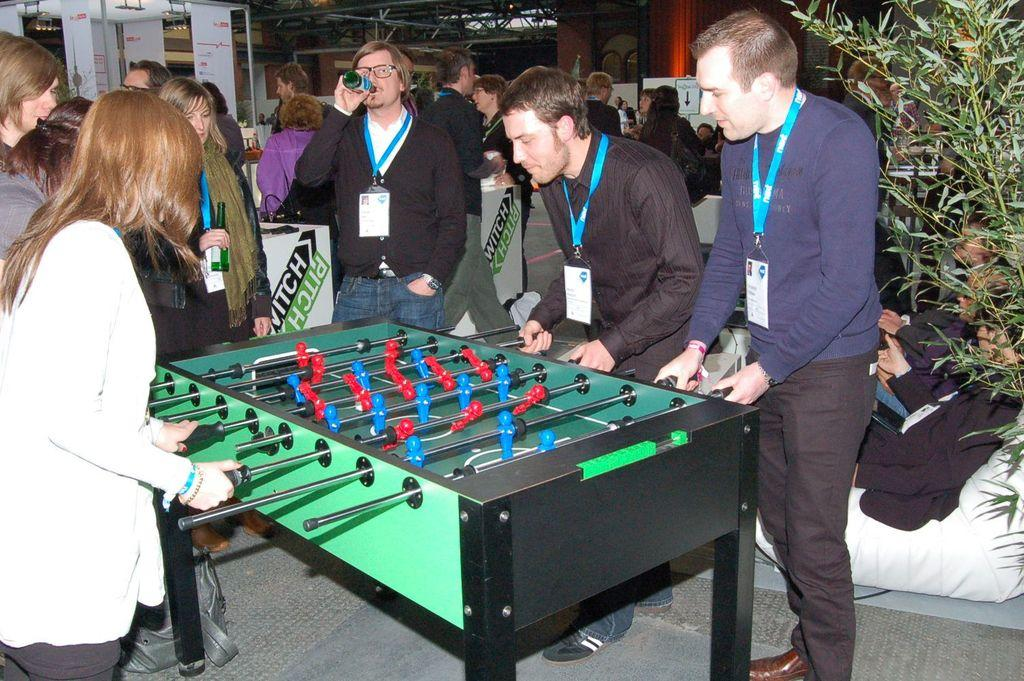What is the main object in the image? There is a game table in the image. What are the people in the image doing? People are playing a game on the table. Can you describe the background of the image? There are other people standing in the background of the image. What can be seen on the right side of the image? There is a tree on the right side of the image. What type of comb is being used by the players to help them win the game? There is no comb present in the image, and the game does not involve the use of a comb. 